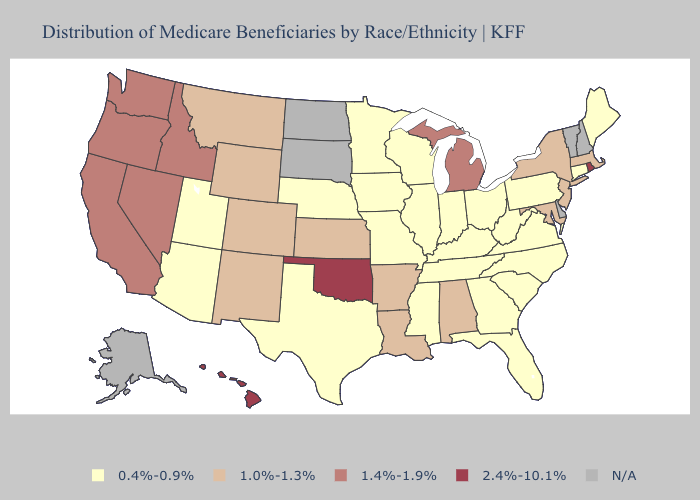Among the states that border Michigan , which have the lowest value?
Concise answer only. Indiana, Ohio, Wisconsin. Does Montana have the lowest value in the USA?
Keep it brief. No. What is the highest value in the USA?
Keep it brief. 2.4%-10.1%. Name the states that have a value in the range 0.4%-0.9%?
Concise answer only. Arizona, Connecticut, Florida, Georgia, Illinois, Indiana, Iowa, Kentucky, Maine, Minnesota, Mississippi, Missouri, Nebraska, North Carolina, Ohio, Pennsylvania, South Carolina, Tennessee, Texas, Utah, Virginia, West Virginia, Wisconsin. Which states have the lowest value in the USA?
Keep it brief. Arizona, Connecticut, Florida, Georgia, Illinois, Indiana, Iowa, Kentucky, Maine, Minnesota, Mississippi, Missouri, Nebraska, North Carolina, Ohio, Pennsylvania, South Carolina, Tennessee, Texas, Utah, Virginia, West Virginia, Wisconsin. Name the states that have a value in the range N/A?
Answer briefly. Alaska, Delaware, New Hampshire, North Dakota, South Dakota, Vermont. Which states hav the highest value in the West?
Concise answer only. Hawaii. Name the states that have a value in the range 1.0%-1.3%?
Short answer required. Alabama, Arkansas, Colorado, Kansas, Louisiana, Maryland, Massachusetts, Montana, New Jersey, New Mexico, New York, Wyoming. Name the states that have a value in the range 0.4%-0.9%?
Be succinct. Arizona, Connecticut, Florida, Georgia, Illinois, Indiana, Iowa, Kentucky, Maine, Minnesota, Mississippi, Missouri, Nebraska, North Carolina, Ohio, Pennsylvania, South Carolina, Tennessee, Texas, Utah, Virginia, West Virginia, Wisconsin. What is the value of North Carolina?
Short answer required. 0.4%-0.9%. Does Minnesota have the highest value in the USA?
Quick response, please. No. What is the value of Nevada?
Concise answer only. 1.4%-1.9%. What is the value of Montana?
Give a very brief answer. 1.0%-1.3%. Does the map have missing data?
Concise answer only. Yes. Does the first symbol in the legend represent the smallest category?
Give a very brief answer. Yes. 